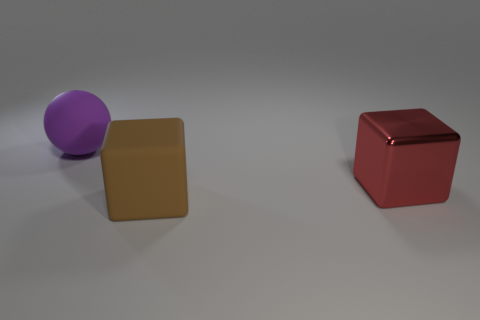Add 1 red things. How many objects exist? 4 Subtract all spheres. How many objects are left? 2 Add 3 brown blocks. How many brown blocks are left? 4 Add 2 purple balls. How many purple balls exist? 3 Subtract 0 yellow cylinders. How many objects are left? 3 Subtract all small green shiny spheres. Subtract all big purple matte things. How many objects are left? 2 